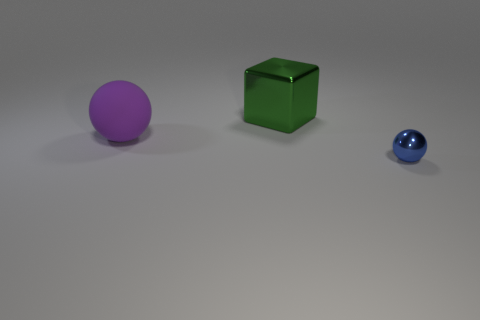Subtract all blue spheres. How many spheres are left? 1 Add 1 big green matte cubes. How many objects exist? 4 Subtract 1 balls. How many balls are left? 1 Subtract all green blocks. Subtract all big green cubes. How many objects are left? 1 Add 3 large purple rubber balls. How many large purple rubber balls are left? 4 Add 1 tiny purple matte spheres. How many tiny purple matte spheres exist? 1 Subtract 0 cyan blocks. How many objects are left? 3 Subtract all spheres. How many objects are left? 1 Subtract all purple cubes. Subtract all purple balls. How many cubes are left? 1 Subtract all gray cylinders. How many purple spheres are left? 1 